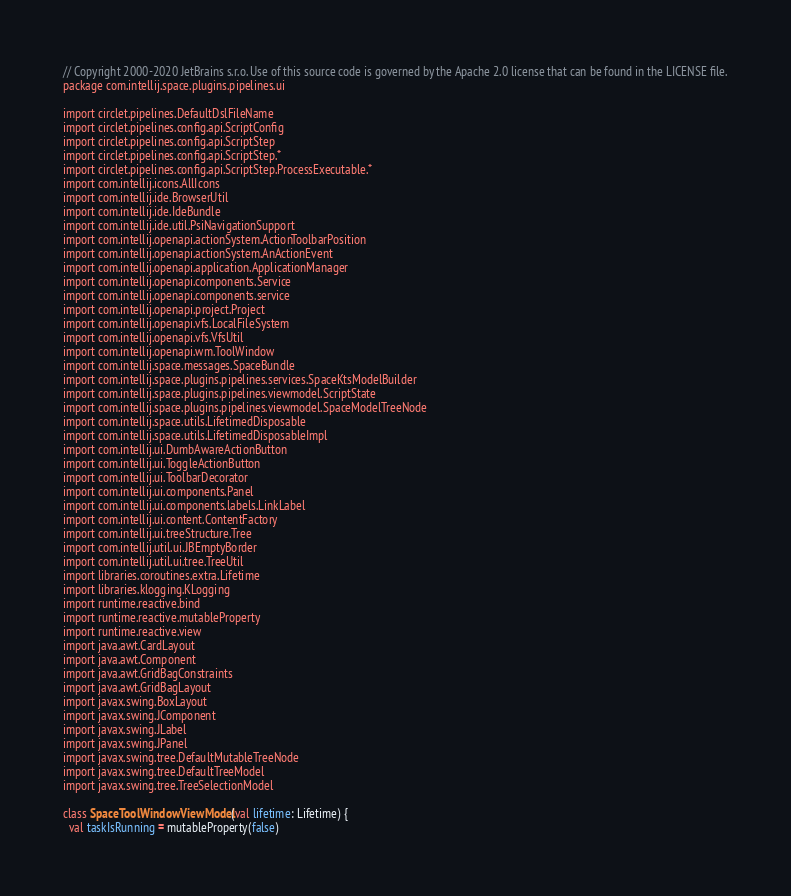<code> <loc_0><loc_0><loc_500><loc_500><_Kotlin_>// Copyright 2000-2020 JetBrains s.r.o. Use of this source code is governed by the Apache 2.0 license that can be found in the LICENSE file.
package com.intellij.space.plugins.pipelines.ui

import circlet.pipelines.DefaultDslFileName
import circlet.pipelines.config.api.ScriptConfig
import circlet.pipelines.config.api.ScriptStep
import circlet.pipelines.config.api.ScriptStep.*
import circlet.pipelines.config.api.ScriptStep.ProcessExecutable.*
import com.intellij.icons.AllIcons
import com.intellij.ide.BrowserUtil
import com.intellij.ide.IdeBundle
import com.intellij.ide.util.PsiNavigationSupport
import com.intellij.openapi.actionSystem.ActionToolbarPosition
import com.intellij.openapi.actionSystem.AnActionEvent
import com.intellij.openapi.application.ApplicationManager
import com.intellij.openapi.components.Service
import com.intellij.openapi.components.service
import com.intellij.openapi.project.Project
import com.intellij.openapi.vfs.LocalFileSystem
import com.intellij.openapi.vfs.VfsUtil
import com.intellij.openapi.wm.ToolWindow
import com.intellij.space.messages.SpaceBundle
import com.intellij.space.plugins.pipelines.services.SpaceKtsModelBuilder
import com.intellij.space.plugins.pipelines.viewmodel.ScriptState
import com.intellij.space.plugins.pipelines.viewmodel.SpaceModelTreeNode
import com.intellij.space.utils.LifetimedDisposable
import com.intellij.space.utils.LifetimedDisposableImpl
import com.intellij.ui.DumbAwareActionButton
import com.intellij.ui.ToggleActionButton
import com.intellij.ui.ToolbarDecorator
import com.intellij.ui.components.Panel
import com.intellij.ui.components.labels.LinkLabel
import com.intellij.ui.content.ContentFactory
import com.intellij.ui.treeStructure.Tree
import com.intellij.util.ui.JBEmptyBorder
import com.intellij.util.ui.tree.TreeUtil
import libraries.coroutines.extra.Lifetime
import libraries.klogging.KLogging
import runtime.reactive.bind
import runtime.reactive.mutableProperty
import runtime.reactive.view
import java.awt.CardLayout
import java.awt.Component
import java.awt.GridBagConstraints
import java.awt.GridBagLayout
import javax.swing.BoxLayout
import javax.swing.JComponent
import javax.swing.JLabel
import javax.swing.JPanel
import javax.swing.tree.DefaultMutableTreeNode
import javax.swing.tree.DefaultTreeModel
import javax.swing.tree.TreeSelectionModel

class SpaceToolWindowViewModel(val lifetime: Lifetime) {
  val taskIsRunning = mutableProperty(false)</code> 